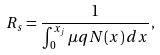<formula> <loc_0><loc_0><loc_500><loc_500>R _ { s } = { \frac { 1 } { \int _ { 0 } ^ { x _ { j } } \mu q N ( x ) \, d x } } ,</formula> 